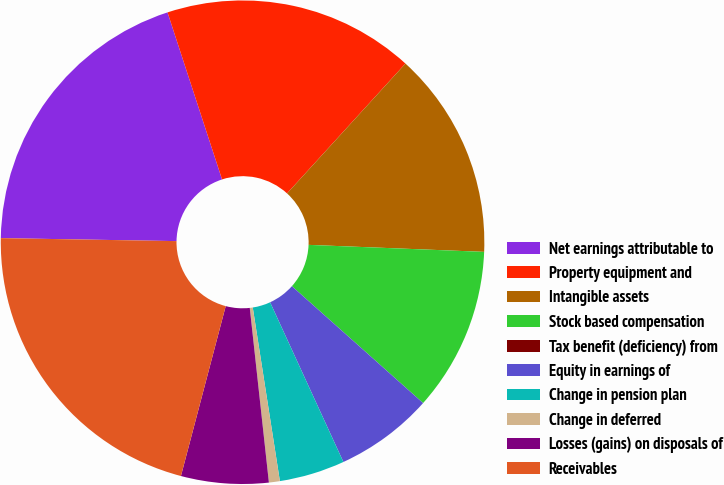Convert chart. <chart><loc_0><loc_0><loc_500><loc_500><pie_chart><fcel>Net earnings attributable to<fcel>Property equipment and<fcel>Intangible assets<fcel>Stock based compensation<fcel>Tax benefit (deficiency) from<fcel>Equity in earnings of<fcel>Change in pension plan<fcel>Change in deferred<fcel>Losses (gains) on disposals of<fcel>Receivables<nl><fcel>19.71%<fcel>16.79%<fcel>13.87%<fcel>10.95%<fcel>0.0%<fcel>6.57%<fcel>4.38%<fcel>0.73%<fcel>5.84%<fcel>21.17%<nl></chart> 